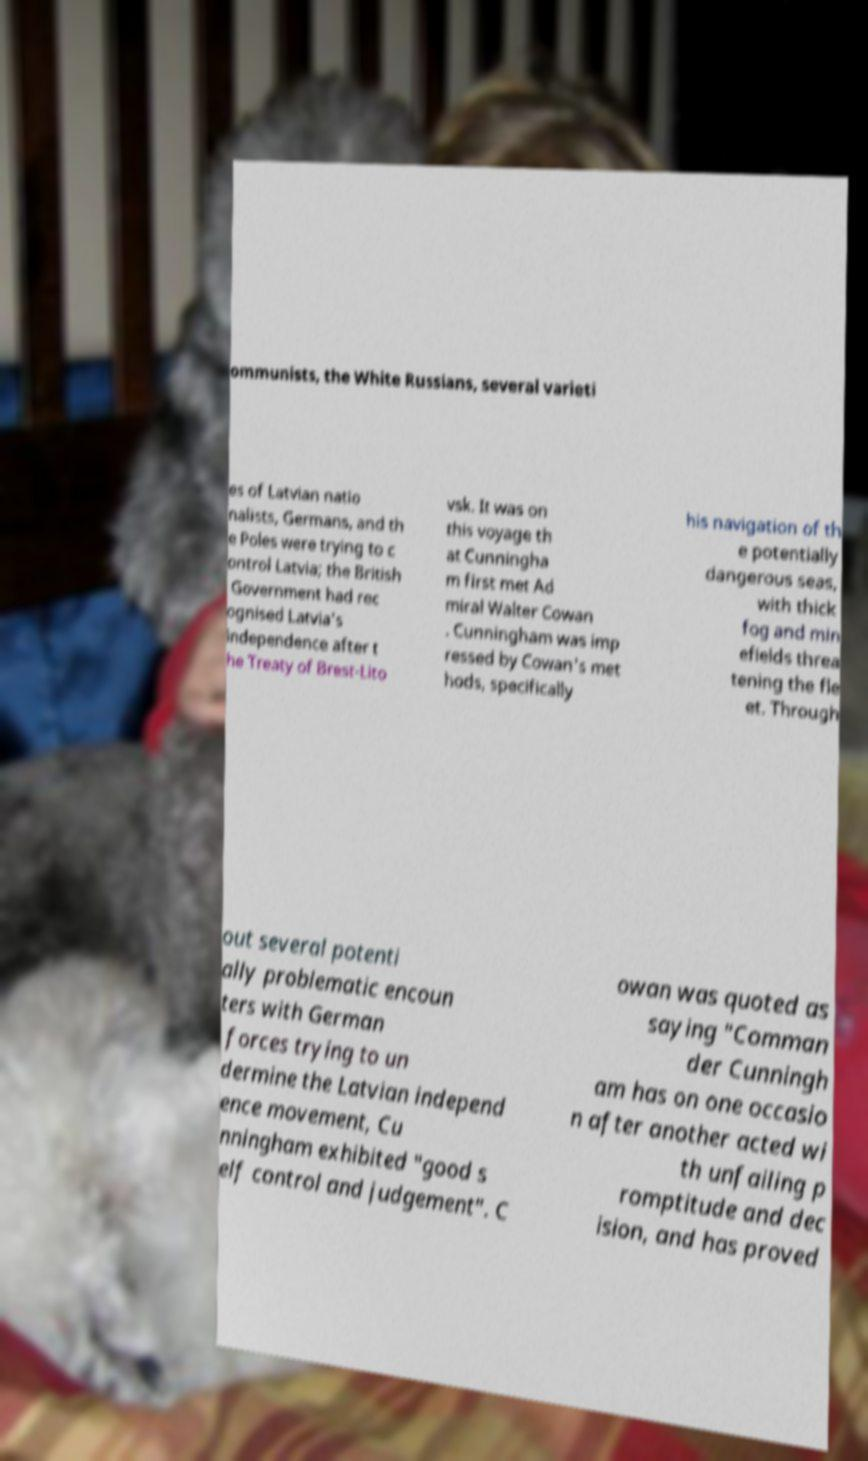I need the written content from this picture converted into text. Can you do that? ommunists, the White Russians, several varieti es of Latvian natio nalists, Germans, and th e Poles were trying to c ontrol Latvia; the British Government had rec ognised Latvia's independence after t he Treaty of Brest-Lito vsk. It was on this voyage th at Cunningha m first met Ad miral Walter Cowan . Cunningham was imp ressed by Cowan's met hods, specifically his navigation of th e potentially dangerous seas, with thick fog and min efields threa tening the fle et. Through out several potenti ally problematic encoun ters with German forces trying to un dermine the Latvian independ ence movement, Cu nningham exhibited "good s elf control and judgement". C owan was quoted as saying "Comman der Cunningh am has on one occasio n after another acted wi th unfailing p romptitude and dec ision, and has proved 